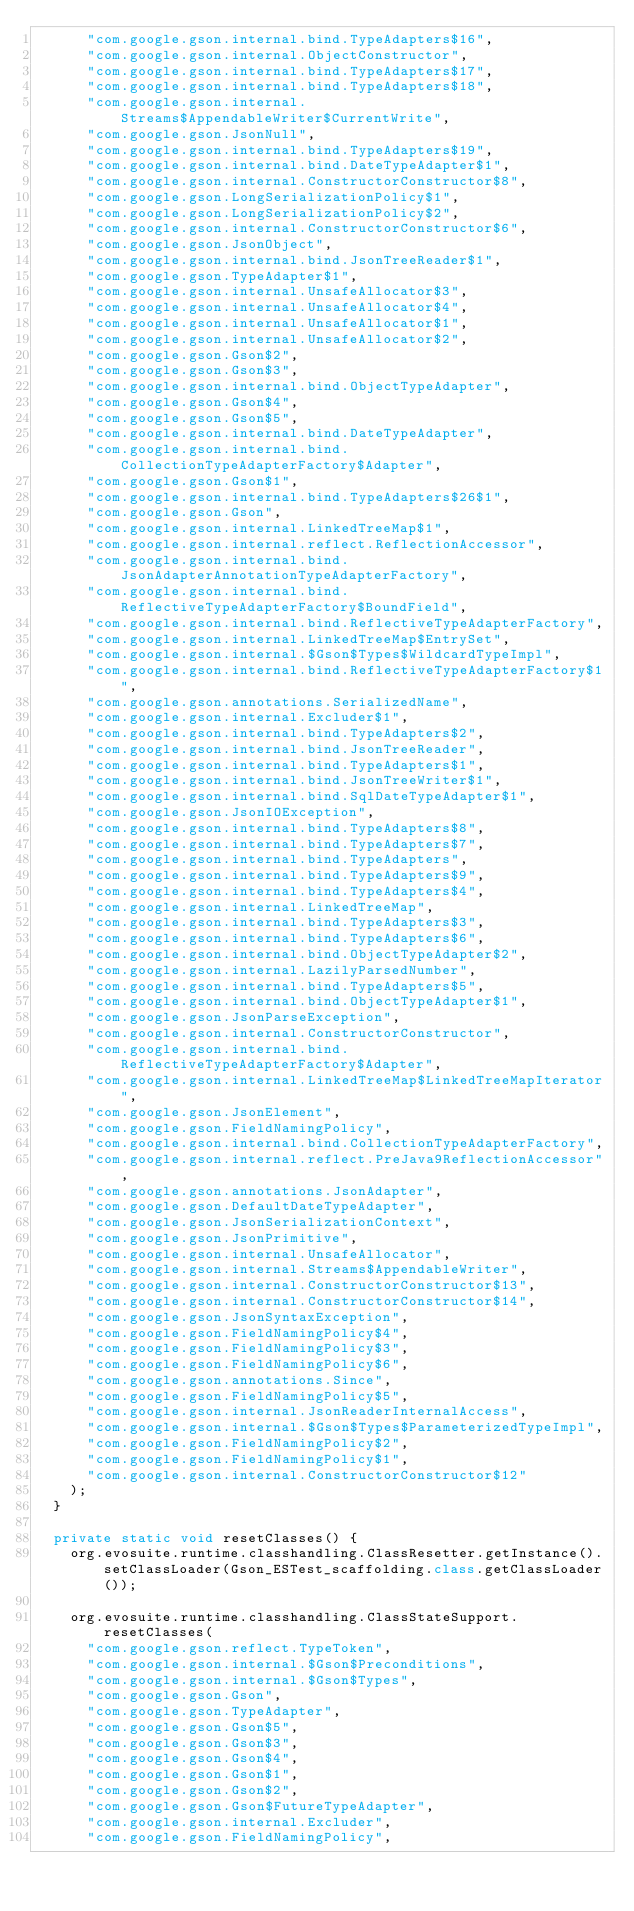Convert code to text. <code><loc_0><loc_0><loc_500><loc_500><_Java_>      "com.google.gson.internal.bind.TypeAdapters$16",
      "com.google.gson.internal.ObjectConstructor",
      "com.google.gson.internal.bind.TypeAdapters$17",
      "com.google.gson.internal.bind.TypeAdapters$18",
      "com.google.gson.internal.Streams$AppendableWriter$CurrentWrite",
      "com.google.gson.JsonNull",
      "com.google.gson.internal.bind.TypeAdapters$19",
      "com.google.gson.internal.bind.DateTypeAdapter$1",
      "com.google.gson.internal.ConstructorConstructor$8",
      "com.google.gson.LongSerializationPolicy$1",
      "com.google.gson.LongSerializationPolicy$2",
      "com.google.gson.internal.ConstructorConstructor$6",
      "com.google.gson.JsonObject",
      "com.google.gson.internal.bind.JsonTreeReader$1",
      "com.google.gson.TypeAdapter$1",
      "com.google.gson.internal.UnsafeAllocator$3",
      "com.google.gson.internal.UnsafeAllocator$4",
      "com.google.gson.internal.UnsafeAllocator$1",
      "com.google.gson.internal.UnsafeAllocator$2",
      "com.google.gson.Gson$2",
      "com.google.gson.Gson$3",
      "com.google.gson.internal.bind.ObjectTypeAdapter",
      "com.google.gson.Gson$4",
      "com.google.gson.Gson$5",
      "com.google.gson.internal.bind.DateTypeAdapter",
      "com.google.gson.internal.bind.CollectionTypeAdapterFactory$Adapter",
      "com.google.gson.Gson$1",
      "com.google.gson.internal.bind.TypeAdapters$26$1",
      "com.google.gson.Gson",
      "com.google.gson.internal.LinkedTreeMap$1",
      "com.google.gson.internal.reflect.ReflectionAccessor",
      "com.google.gson.internal.bind.JsonAdapterAnnotationTypeAdapterFactory",
      "com.google.gson.internal.bind.ReflectiveTypeAdapterFactory$BoundField",
      "com.google.gson.internal.bind.ReflectiveTypeAdapterFactory",
      "com.google.gson.internal.LinkedTreeMap$EntrySet",
      "com.google.gson.internal.$Gson$Types$WildcardTypeImpl",
      "com.google.gson.internal.bind.ReflectiveTypeAdapterFactory$1",
      "com.google.gson.annotations.SerializedName",
      "com.google.gson.internal.Excluder$1",
      "com.google.gson.internal.bind.TypeAdapters$2",
      "com.google.gson.internal.bind.JsonTreeReader",
      "com.google.gson.internal.bind.TypeAdapters$1",
      "com.google.gson.internal.bind.JsonTreeWriter$1",
      "com.google.gson.internal.bind.SqlDateTypeAdapter$1",
      "com.google.gson.JsonIOException",
      "com.google.gson.internal.bind.TypeAdapters$8",
      "com.google.gson.internal.bind.TypeAdapters$7",
      "com.google.gson.internal.bind.TypeAdapters",
      "com.google.gson.internal.bind.TypeAdapters$9",
      "com.google.gson.internal.bind.TypeAdapters$4",
      "com.google.gson.internal.LinkedTreeMap",
      "com.google.gson.internal.bind.TypeAdapters$3",
      "com.google.gson.internal.bind.TypeAdapters$6",
      "com.google.gson.internal.bind.ObjectTypeAdapter$2",
      "com.google.gson.internal.LazilyParsedNumber",
      "com.google.gson.internal.bind.TypeAdapters$5",
      "com.google.gson.internal.bind.ObjectTypeAdapter$1",
      "com.google.gson.JsonParseException",
      "com.google.gson.internal.ConstructorConstructor",
      "com.google.gson.internal.bind.ReflectiveTypeAdapterFactory$Adapter",
      "com.google.gson.internal.LinkedTreeMap$LinkedTreeMapIterator",
      "com.google.gson.JsonElement",
      "com.google.gson.FieldNamingPolicy",
      "com.google.gson.internal.bind.CollectionTypeAdapterFactory",
      "com.google.gson.internal.reflect.PreJava9ReflectionAccessor",
      "com.google.gson.annotations.JsonAdapter",
      "com.google.gson.DefaultDateTypeAdapter",
      "com.google.gson.JsonSerializationContext",
      "com.google.gson.JsonPrimitive",
      "com.google.gson.internal.UnsafeAllocator",
      "com.google.gson.internal.Streams$AppendableWriter",
      "com.google.gson.internal.ConstructorConstructor$13",
      "com.google.gson.internal.ConstructorConstructor$14",
      "com.google.gson.JsonSyntaxException",
      "com.google.gson.FieldNamingPolicy$4",
      "com.google.gson.FieldNamingPolicy$3",
      "com.google.gson.FieldNamingPolicy$6",
      "com.google.gson.annotations.Since",
      "com.google.gson.FieldNamingPolicy$5",
      "com.google.gson.internal.JsonReaderInternalAccess",
      "com.google.gson.internal.$Gson$Types$ParameterizedTypeImpl",
      "com.google.gson.FieldNamingPolicy$2",
      "com.google.gson.FieldNamingPolicy$1",
      "com.google.gson.internal.ConstructorConstructor$12"
    );
  } 

  private static void resetClasses() {
    org.evosuite.runtime.classhandling.ClassResetter.getInstance().setClassLoader(Gson_ESTest_scaffolding.class.getClassLoader()); 

    org.evosuite.runtime.classhandling.ClassStateSupport.resetClasses(
      "com.google.gson.reflect.TypeToken",
      "com.google.gson.internal.$Gson$Preconditions",
      "com.google.gson.internal.$Gson$Types",
      "com.google.gson.Gson",
      "com.google.gson.TypeAdapter",
      "com.google.gson.Gson$5",
      "com.google.gson.Gson$3",
      "com.google.gson.Gson$4",
      "com.google.gson.Gson$1",
      "com.google.gson.Gson$2",
      "com.google.gson.Gson$FutureTypeAdapter",
      "com.google.gson.internal.Excluder",
      "com.google.gson.FieldNamingPolicy",</code> 